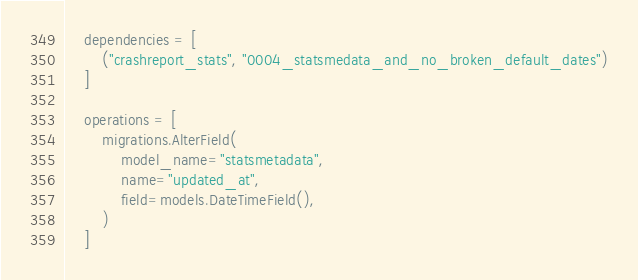Convert code to text. <code><loc_0><loc_0><loc_500><loc_500><_Python_>    dependencies = [
        ("crashreport_stats", "0004_statsmedata_and_no_broken_default_dates")
    ]

    operations = [
        migrations.AlterField(
            model_name="statsmetadata",
            name="updated_at",
            field=models.DateTimeField(),
        )
    ]
</code> 